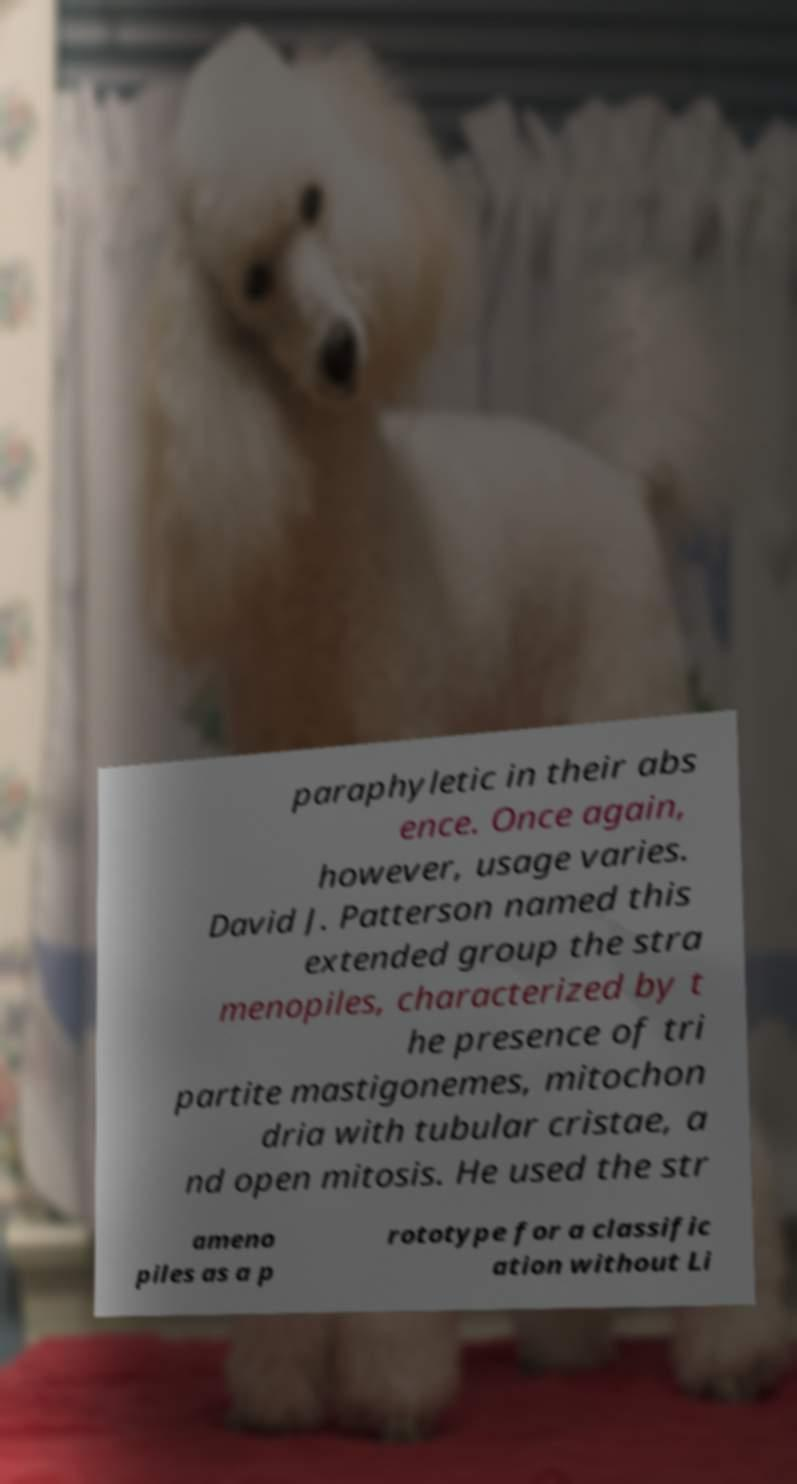I need the written content from this picture converted into text. Can you do that? paraphyletic in their abs ence. Once again, however, usage varies. David J. Patterson named this extended group the stra menopiles, characterized by t he presence of tri partite mastigonemes, mitochon dria with tubular cristae, a nd open mitosis. He used the str ameno piles as a p rototype for a classific ation without Li 